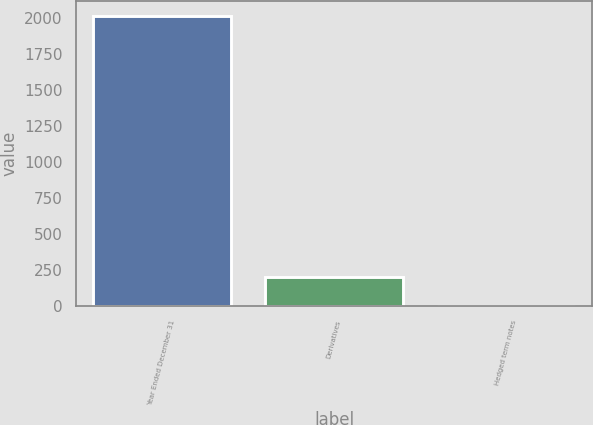<chart> <loc_0><loc_0><loc_500><loc_500><bar_chart><fcel>Year Ended December 31<fcel>Derivatives<fcel>Hedged term notes<nl><fcel>2017<fcel>203.05<fcel>1.5<nl></chart> 